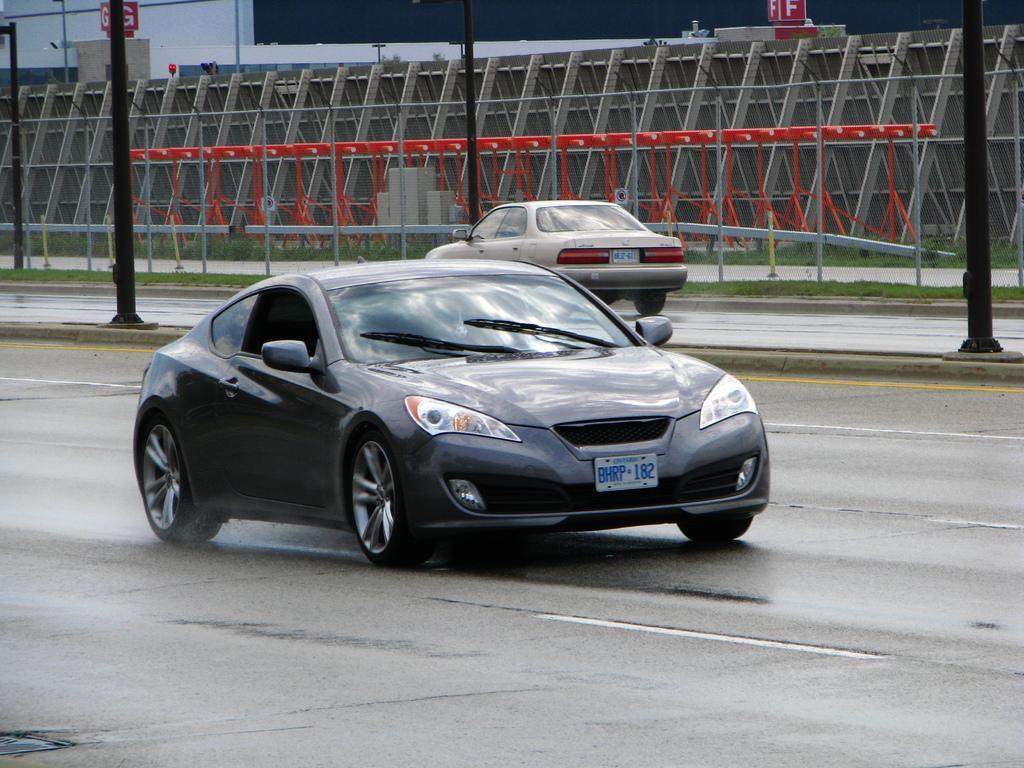Could you give a brief overview of what you see in this image? In this image there are two cars on the roads , and in the background there are poles, boards, iron rods, grass. 